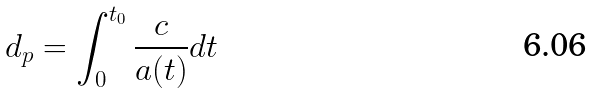Convert formula to latex. <formula><loc_0><loc_0><loc_500><loc_500>d _ { p } = \int _ { 0 } ^ { t _ { 0 } } \frac { c } { a ( t ) } d t</formula> 